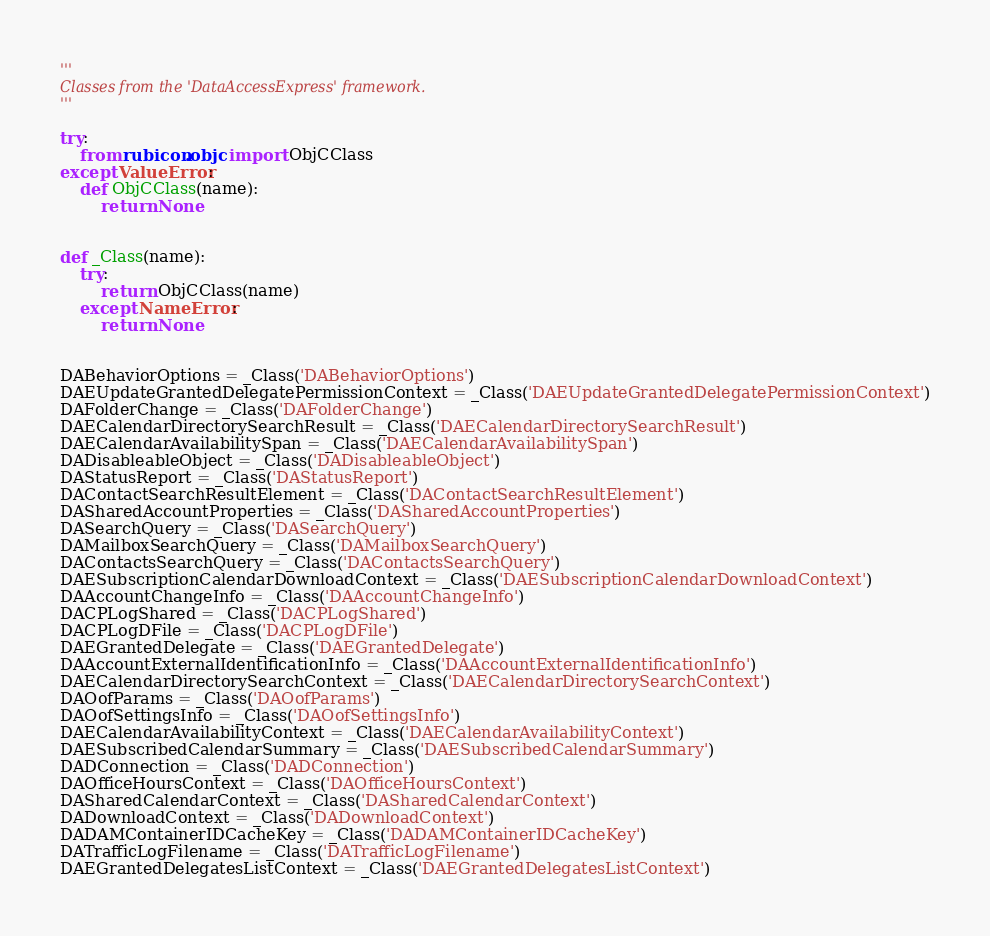Convert code to text. <code><loc_0><loc_0><loc_500><loc_500><_Python_>'''
Classes from the 'DataAccessExpress' framework.
'''

try:
    from rubicon.objc import ObjCClass
except ValueError:
    def ObjCClass(name):
        return None


def _Class(name):
    try:
        return ObjCClass(name)
    except NameError:
        return None

    
DABehaviorOptions = _Class('DABehaviorOptions')
DAEUpdateGrantedDelegatePermissionContext = _Class('DAEUpdateGrantedDelegatePermissionContext')
DAFolderChange = _Class('DAFolderChange')
DAECalendarDirectorySearchResult = _Class('DAECalendarDirectorySearchResult')
DAECalendarAvailabilitySpan = _Class('DAECalendarAvailabilitySpan')
DADisableableObject = _Class('DADisableableObject')
DAStatusReport = _Class('DAStatusReport')
DAContactSearchResultElement = _Class('DAContactSearchResultElement')
DASharedAccountProperties = _Class('DASharedAccountProperties')
DASearchQuery = _Class('DASearchQuery')
DAMailboxSearchQuery = _Class('DAMailboxSearchQuery')
DAContactsSearchQuery = _Class('DAContactsSearchQuery')
DAESubscriptionCalendarDownloadContext = _Class('DAESubscriptionCalendarDownloadContext')
DAAccountChangeInfo = _Class('DAAccountChangeInfo')
DACPLogShared = _Class('DACPLogShared')
DACPLogDFile = _Class('DACPLogDFile')
DAEGrantedDelegate = _Class('DAEGrantedDelegate')
DAAccountExternalIdentificationInfo = _Class('DAAccountExternalIdentificationInfo')
DAECalendarDirectorySearchContext = _Class('DAECalendarDirectorySearchContext')
DAOofParams = _Class('DAOofParams')
DAOofSettingsInfo = _Class('DAOofSettingsInfo')
DAECalendarAvailabilityContext = _Class('DAECalendarAvailabilityContext')
DAESubscribedCalendarSummary = _Class('DAESubscribedCalendarSummary')
DADConnection = _Class('DADConnection')
DAOfficeHoursContext = _Class('DAOfficeHoursContext')
DASharedCalendarContext = _Class('DASharedCalendarContext')
DADownloadContext = _Class('DADownloadContext')
DADAMContainerIDCacheKey = _Class('DADAMContainerIDCacheKey')
DATrafficLogFilename = _Class('DATrafficLogFilename')
DAEGrantedDelegatesListContext = _Class('DAEGrantedDelegatesListContext')
</code> 